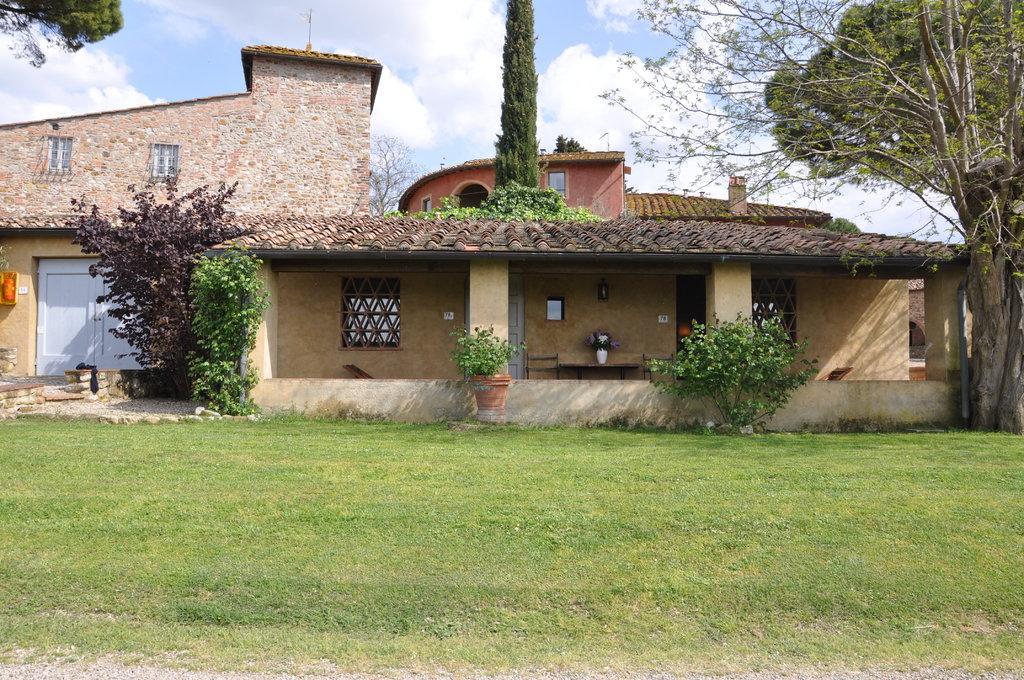How would you summarize this image in a sentence or two? In the image there is a building in the back with a garden in front of it along with plants on either sides and above its sky with clouds. 